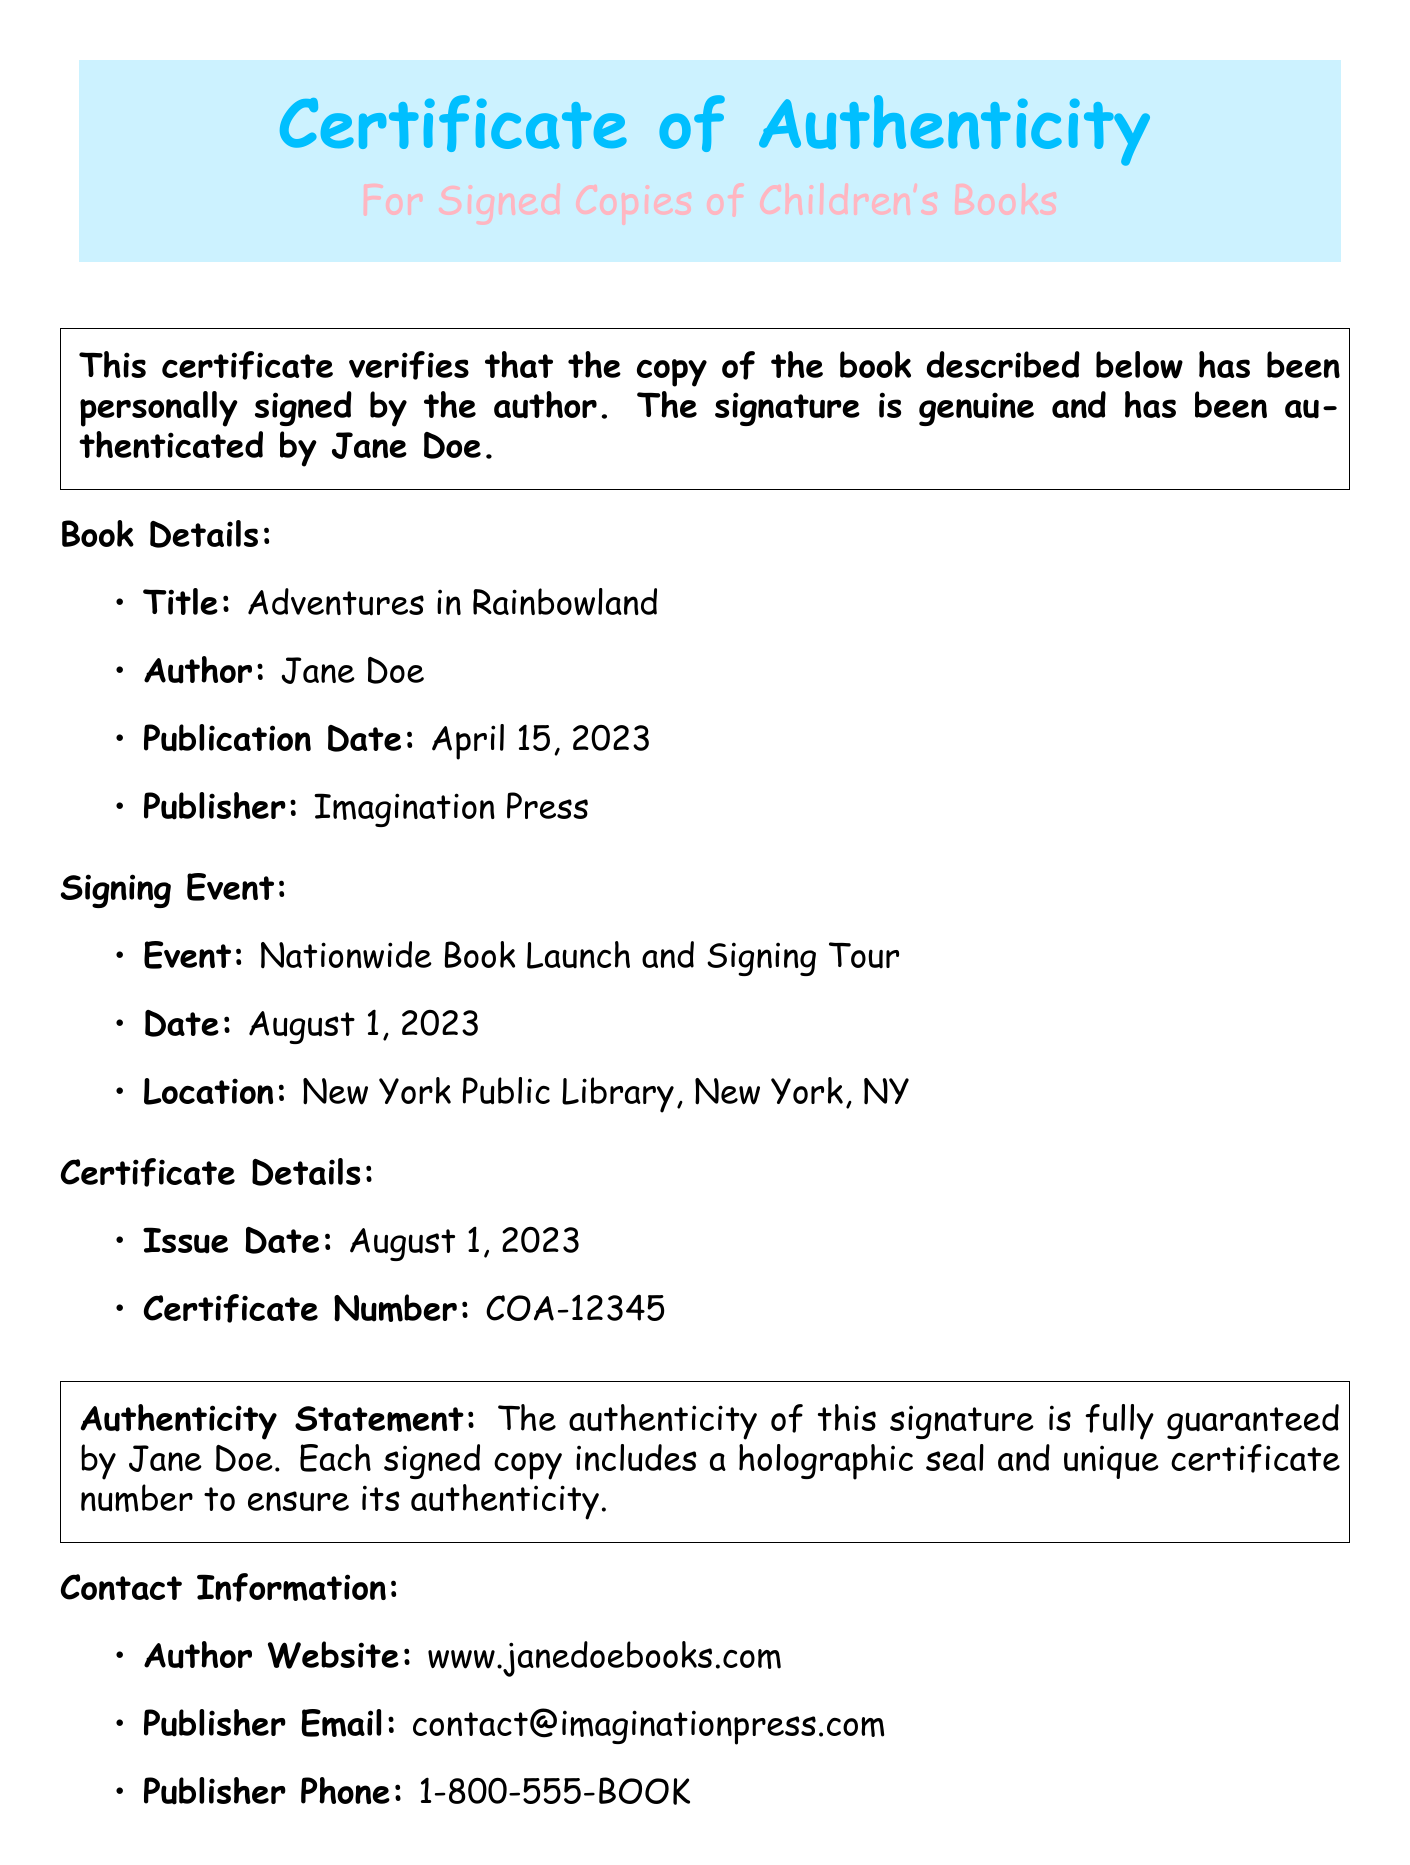What is the title of the book? The title of the book is presented in the document under Book Details.
Answer: Adventures in Rainbowland Who is the author of the book? The author is mentioned in the Book Details section.
Answer: Jane Doe When was the book published? The publication date is stated in the Book Details section.
Answer: April 15, 2023 What is the certificate number? The certificate number is specified in the Certificate Details section.
Answer: COA-12345 Where is the book signing event held? The location is provided in the Signing Event section.
Answer: New York Public Library, New York, NY What is guaranteed by Jane Doe? The authenticity statement indicates what is guaranteed by the author.
Answer: Authenticity of this signature What special feature accompanies each signed copy? The authenticity statement section outlines the special feature with each signed copy.
Answer: Holographic seal What is the issue date of the certificate? The issue date is listed in the Certificate Details section of the document.
Answer: August 1, 2023 How can I verify this certificate? The document provides contact information for verification in the last section.
Answer: Author website or publisher contact information 